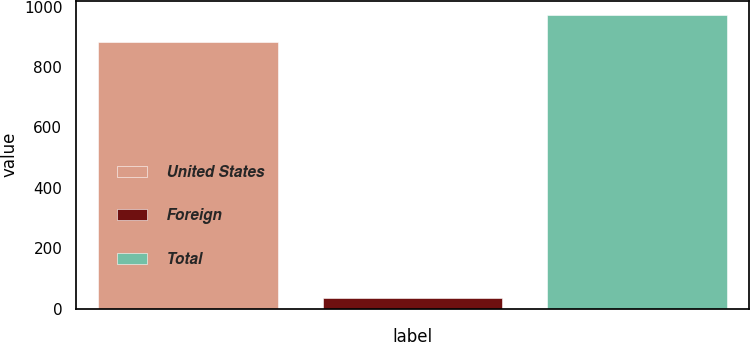Convert chart to OTSL. <chart><loc_0><loc_0><loc_500><loc_500><bar_chart><fcel>United States<fcel>Foreign<fcel>Total<nl><fcel>883<fcel>37<fcel>971.3<nl></chart> 